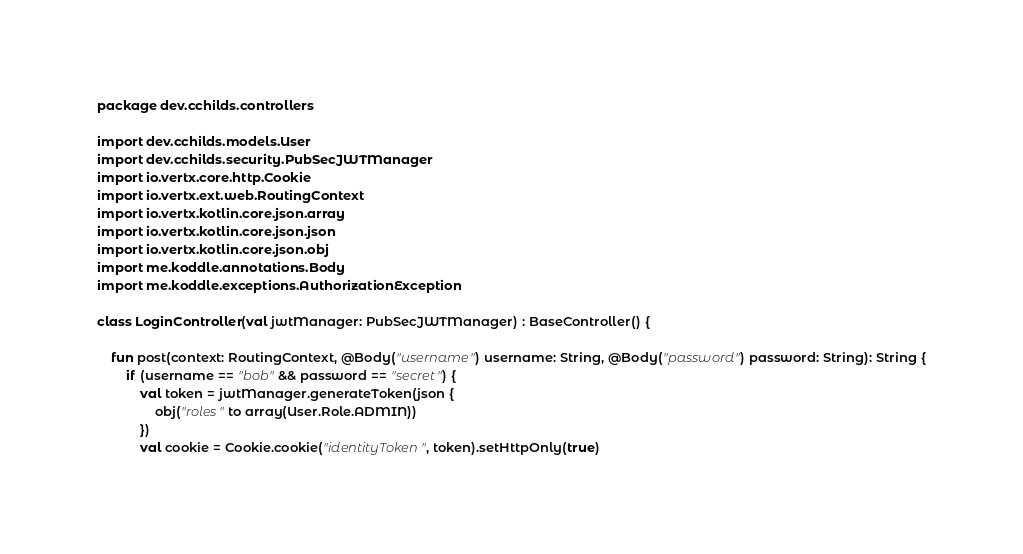Convert code to text. <code><loc_0><loc_0><loc_500><loc_500><_Kotlin_>package dev.cchilds.controllers

import dev.cchilds.models.User
import dev.cchilds.security.PubSecJWTManager
import io.vertx.core.http.Cookie
import io.vertx.ext.web.RoutingContext
import io.vertx.kotlin.core.json.array
import io.vertx.kotlin.core.json.json
import io.vertx.kotlin.core.json.obj
import me.koddle.annotations.Body
import me.koddle.exceptions.AuthorizationException

class LoginController(val jwtManager: PubSecJWTManager) : BaseController() {

    fun post(context: RoutingContext, @Body("username") username: String, @Body("password") password: String): String {
        if (username == "bob" && password == "secret") {
            val token = jwtManager.generateToken(json {
                obj("roles" to array(User.Role.ADMIN))
            })
            val cookie = Cookie.cookie("identityToken", token).setHttpOnly(true)</code> 